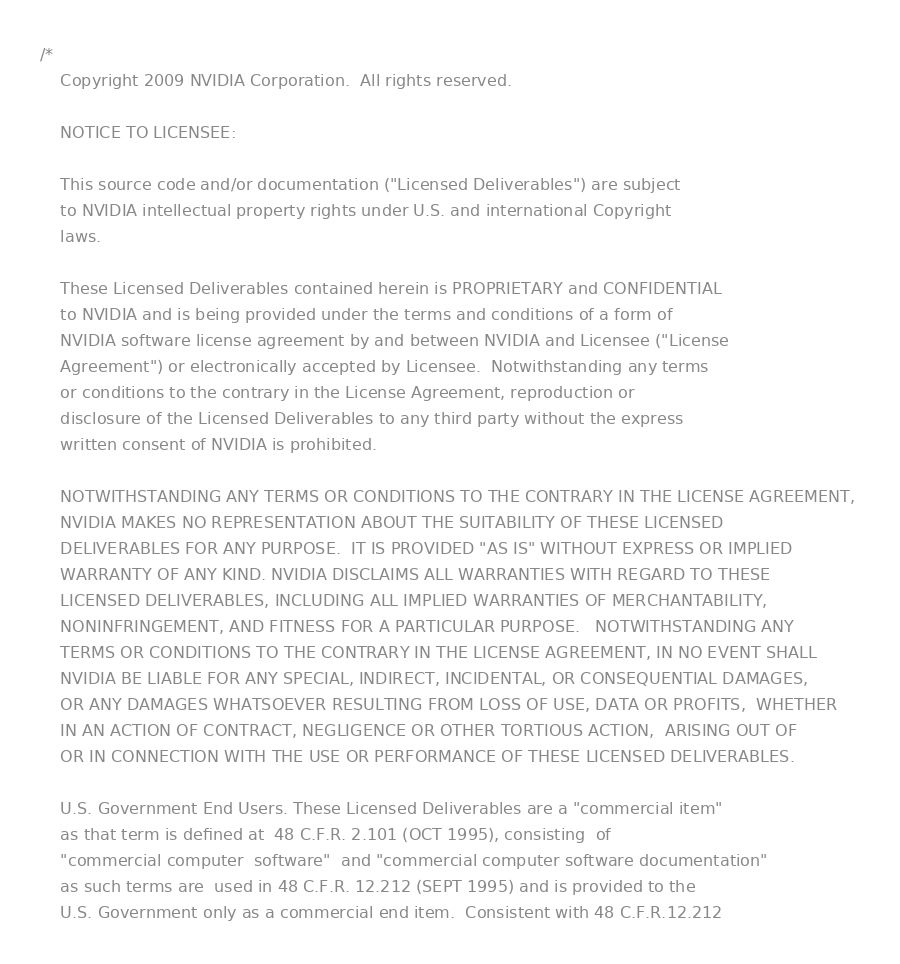Convert code to text. <code><loc_0><loc_0><loc_500><loc_500><_Cuda_>/*
	Copyright 2009 NVIDIA Corporation.  All rights reserved.

	NOTICE TO LICENSEE:   

	This source code and/or documentation ("Licensed Deliverables") are subject 
	to NVIDIA intellectual property rights under U.S. and international Copyright 
	laws.  

	These Licensed Deliverables contained herein is PROPRIETARY and CONFIDENTIAL 
	to NVIDIA and is being provided under the terms and conditions of a form of 
	NVIDIA software license agreement by and between NVIDIA and Licensee ("License 
	Agreement") or electronically accepted by Licensee.  Notwithstanding any terms 
	or conditions to the contrary in the License Agreement, reproduction or 
	disclosure of the Licensed Deliverables to any third party without the express 
	written consent of NVIDIA is prohibited.     

	NOTWITHSTANDING ANY TERMS OR CONDITIONS TO THE CONTRARY IN THE LICENSE AGREEMENT, 
	NVIDIA MAKES NO REPRESENTATION ABOUT THE SUITABILITY OF THESE LICENSED 
	DELIVERABLES FOR ANY PURPOSE.  IT IS PROVIDED "AS IS" WITHOUT EXPRESS OR IMPLIED 
	WARRANTY OF ANY KIND. NVIDIA DISCLAIMS ALL WARRANTIES WITH REGARD TO THESE 
	LICENSED DELIVERABLES, INCLUDING ALL IMPLIED WARRANTIES OF MERCHANTABILITY, 
	NONINFRINGEMENT, AND FITNESS FOR A PARTICULAR PURPOSE.   NOTWITHSTANDING ANY 
	TERMS OR CONDITIONS TO THE CONTRARY IN THE LICENSE AGREEMENT, IN NO EVENT SHALL 
	NVIDIA BE LIABLE FOR ANY SPECIAL, INDIRECT, INCIDENTAL, OR CONSEQUENTIAL DAMAGES, 
	OR ANY DAMAGES WHATSOEVER RESULTING FROM LOSS OF USE, DATA OR PROFITS,	WHETHER 
	IN AN ACTION OF CONTRACT, NEGLIGENCE OR OTHER TORTIOUS ACTION,  ARISING OUT OF 
	OR IN CONNECTION WITH THE USE OR PERFORMANCE OF THESE LICENSED DELIVERABLES.  

	U.S. Government End Users. These Licensed Deliverables are a "commercial item" 
	as that term is defined at  48 C.F.R. 2.101 (OCT 1995), consisting  of 
	"commercial computer  software"  and "commercial computer software documentation" 
	as such terms are  used in 48 C.F.R. 12.212 (SEPT 1995) and is provided to the 
	U.S. Government only as a commercial end item.  Consistent with 48 C.F.R.12.212 </code> 